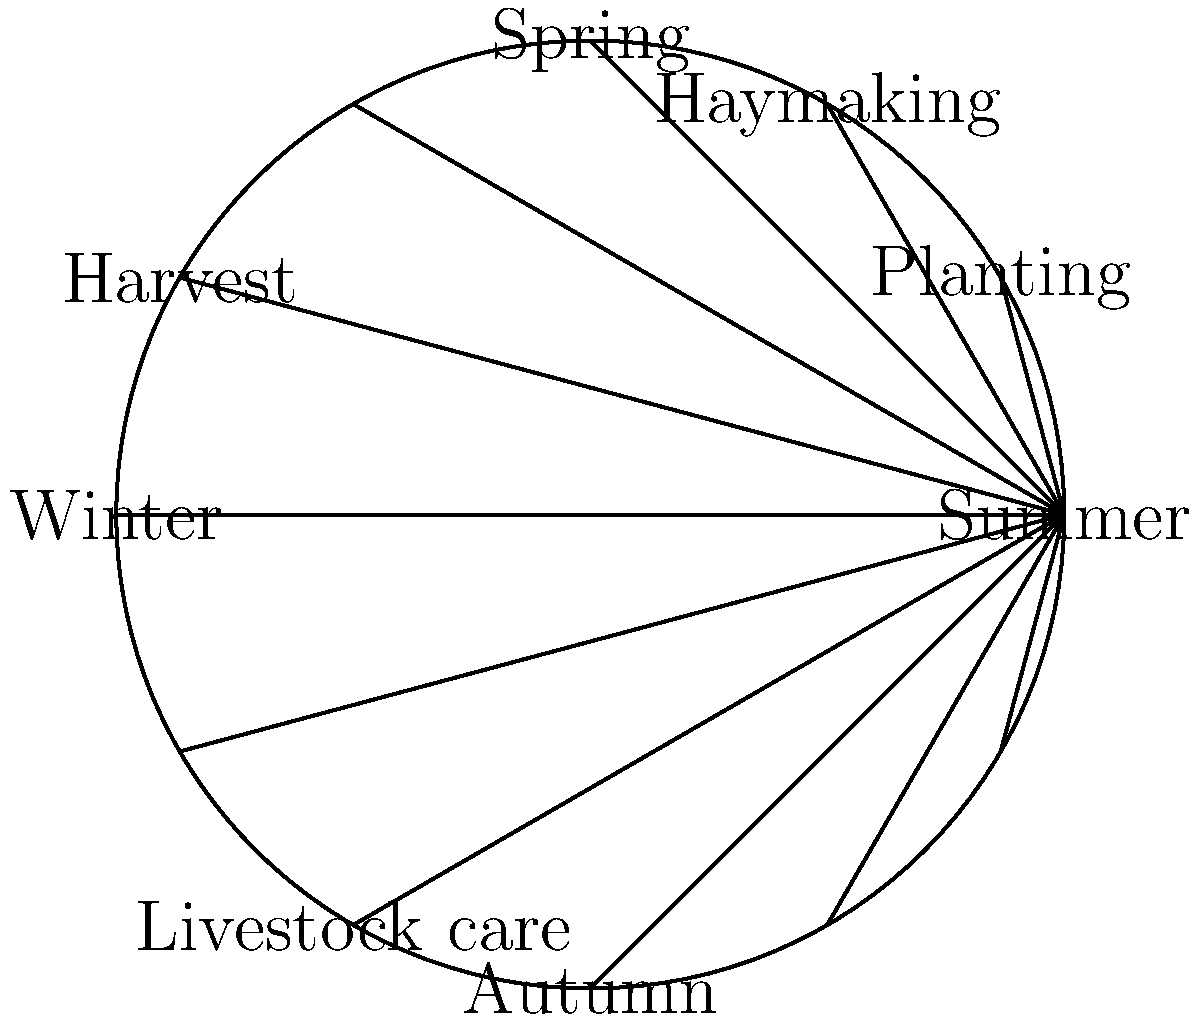Based on the circular calendar diagram of traditional Irish farming practices, which activity is most closely associated with the transition from summer to autumn, and why is this timing crucial for the agricultural cycle? To answer this question, let's analyze the circular calendar diagram step-by-step:

1. The diagram is divided into four main seasons: Spring, Summer, Autumn, and Winter.

2. Various farming activities are placed around the circle, corresponding to their typical timing in the agricultural year.

3. Moving clockwise from Summer to Autumn, we see that "Harvest" is positioned at this transition point.

4. The harvest is crucial at this time for several reasons:
   a) Crops planted in spring have reached maturity by late summer/early autumn.
   b) Weather conditions are generally still favorable for harvesting before the onset of autumn rains.
   c) Harvesting at this time ensures maximum yield and quality of crops.
   d) It allows farmers to store food for livestock and people during the upcoming winter months.
   e) Timely harvesting also prepares the fields for any autumn planting or winter preparations.

5. In traditional Irish farming, the harvest period (often called the "harvest season" or "Lughnasadh" in Gaelic tradition) was a time of intense activity and community cooperation.

6. The successful completion of the harvest was critical for the community's survival through the winter and for having seeds for the next planting season.

Therefore, the harvest activity at the summer-autumn transition is crucial as it represents the culmination of the growing season and the preparation for the leaner winter months ahead.
Answer: Harvest; it marks the culmination of the growing season and prepares for winter. 